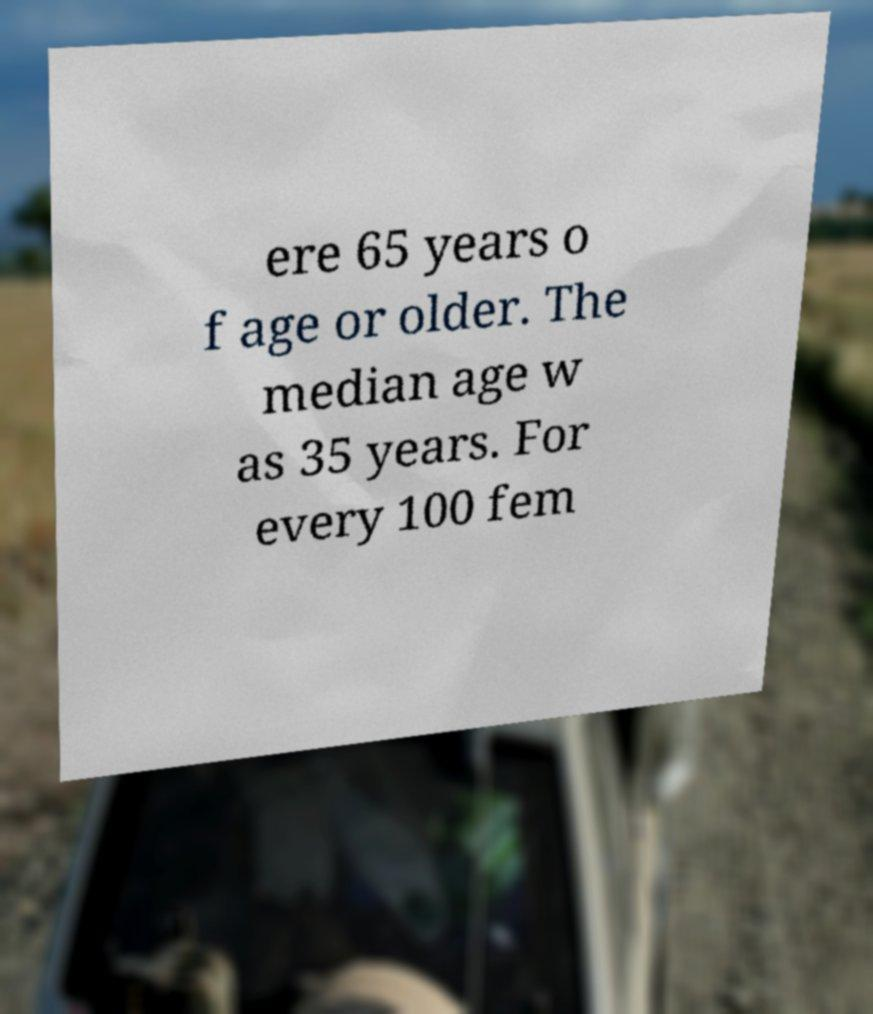Please read and relay the text visible in this image. What does it say? ere 65 years o f age or older. The median age w as 35 years. For every 100 fem 